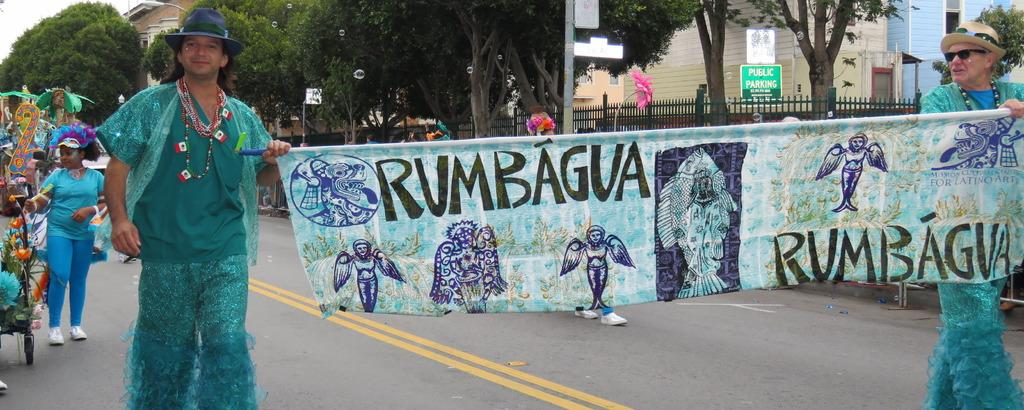How many people are in the image? There are two men in the image. What are the men wearing? The men are wearing blue costumes. What are the men holding in the image? The men are holding a banner. What are the men doing in the image? The men are walking on the street. What can be seen in the background of the image? There are black grills and trees visible in the background. How many babies are visible in the image? There are no babies present in the image; it features two men walking on the street while holding a banner. What type of finger is the man using to hold the banner in the image? There is no specific finger mentioned or visible in the image; the men are simply holding the banner with their hands. 